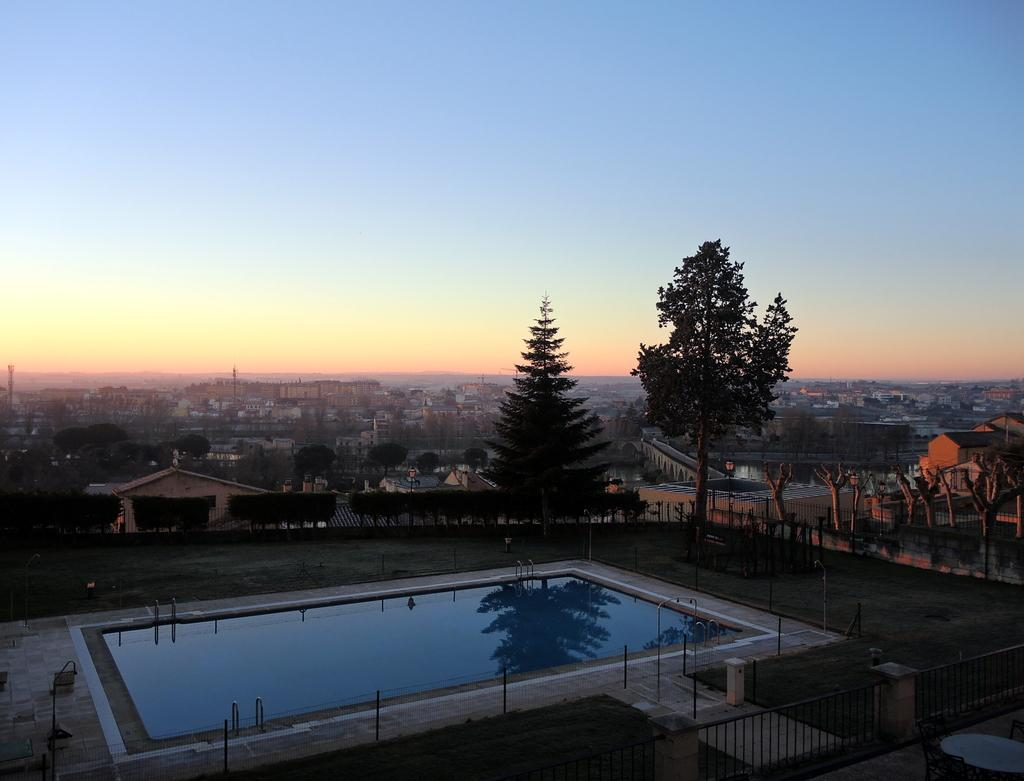What is the main feature in the image? There is a swimming pool in the image. What can be seen around the swimming pool? There are plants, trees, and buildings around the pool. Can you describe the railing in the image? There is a railing in the foreground of the image. What type of paste is being used to hold the sand together in the image? There is no sand or paste present in the image; it features a swimming pool with plants, trees, and buildings around it. 